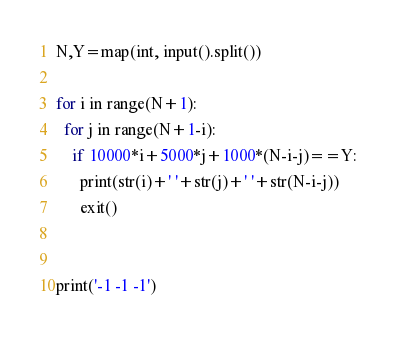<code> <loc_0><loc_0><loc_500><loc_500><_Python_>N,Y=map(int, input().split())

for i in range(N+1):
  for j in range(N+1-i):
    if 10000*i+5000*j+1000*(N-i-j)==Y:
      print(str(i)+' '+str(j)+' '+str(N-i-j))
      exit()
        
    
print('-1 -1 -1')
</code> 